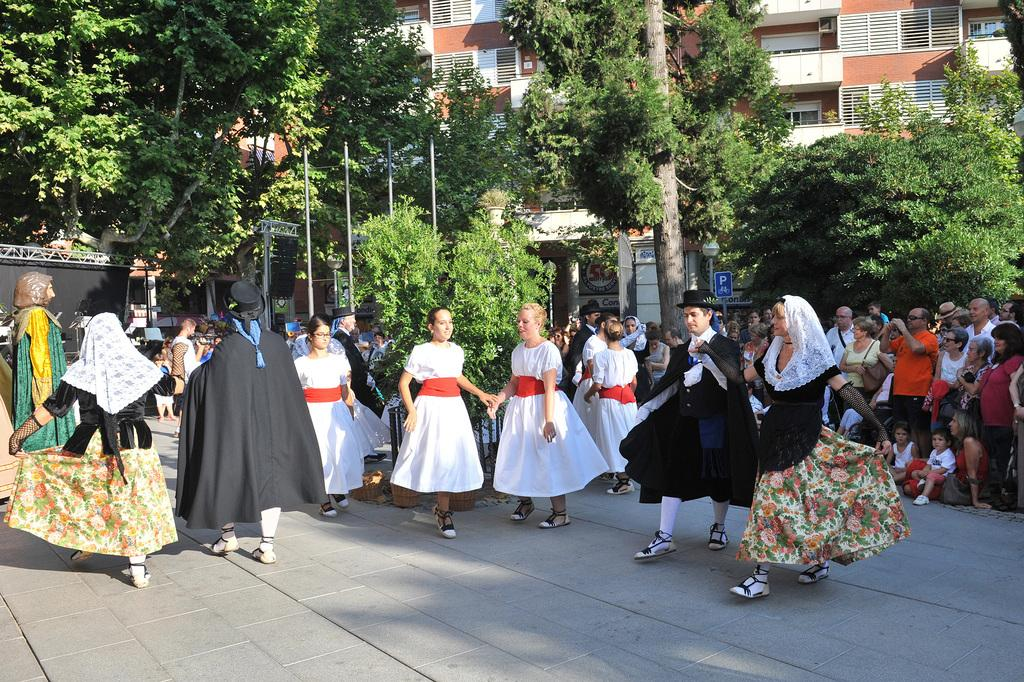What are the people in the center of the image wearing? The people in the center of the image are wearing costumes. What can be seen on the right side of the image? There is a crowd on the right side of the image. What is visible in the background of the image? There are trees, poles, and buildings in the background of the image. Can you identify any specific object in the image? Yes, there is a sign board visible in the image. How many ducks are sitting on the fire in the image? There are no ducks or fire present in the image. What type of feather can be seen on the people wearing costumes in the image? There is no mention of feathers on the people wearing costumes in the image. 